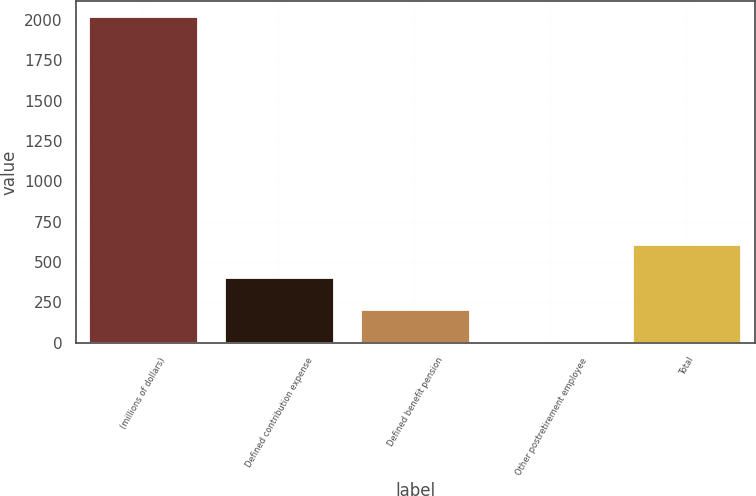<chart> <loc_0><loc_0><loc_500><loc_500><bar_chart><fcel>(millions of dollars)<fcel>Defined contribution expense<fcel>Defined benefit pension<fcel>Other postretirement employee<fcel>Total<nl><fcel>2016<fcel>404.32<fcel>202.86<fcel>1.4<fcel>605.78<nl></chart> 